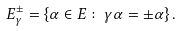<formula> <loc_0><loc_0><loc_500><loc_500>E _ { \gamma } ^ { \pm } = \left \{ \alpha \in E \colon \gamma \alpha = \pm \alpha \right \} .</formula> 